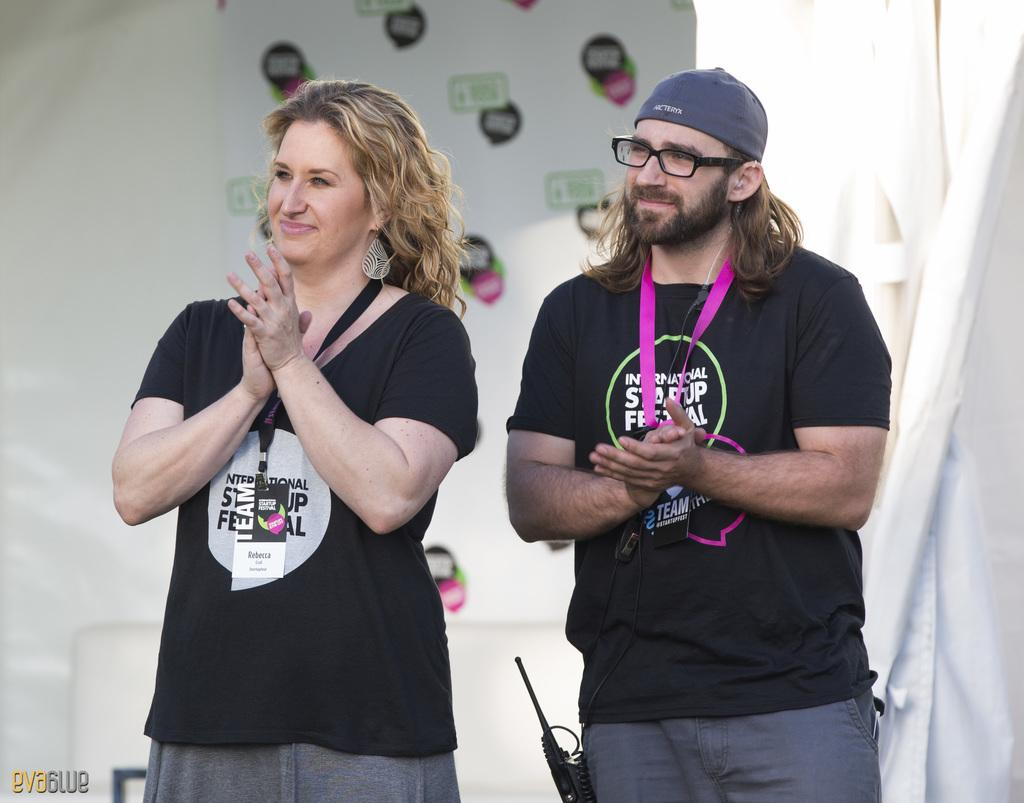How many people are present in the image? There are two people in the image, a woman and a man. What are the people wearing in the image? Both the woman and the man are wearing black color t-shirts. What is the color of the background in the image? The background of the image is white. Reasoning: Let's think step by following the guidelines to produce the conversation. We start by identifying the main subjects in the image, which are the woman and the man. Then, we describe their clothing, noting that they are both wearing black t-shirts. Finally, we describe the background color, which is white. Each question is designed to elicit a specific detail about the image that is known from the provided facts. Absurd Question/Answer: What type of advertisement can be seen on the church in the image? There is no church or advertisement present in the image. What kind of house is visible in the background of the image? There is no house visible in the image; the background is white. What type of advertisement can be seen on the church in the image? There is no church or advertisement present in the image. What kind of house is visible in the background of the image? There is no house visible in the image; the background is white. 